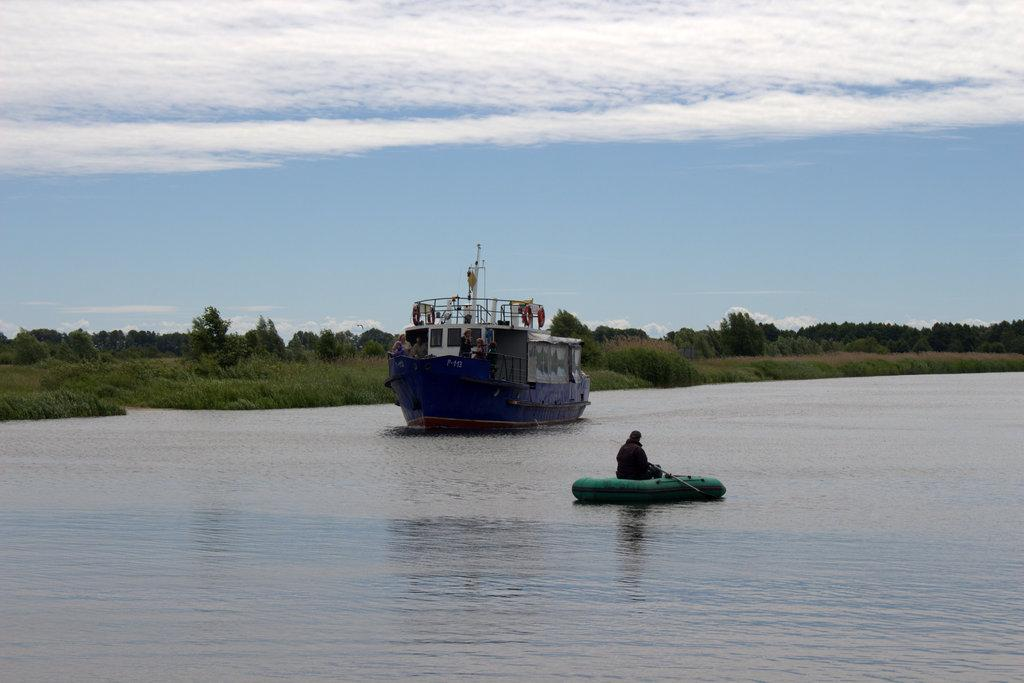What is floating on the water in the image? There are boats floating on the water in the image. What else can be seen in the middle of the image besides the boats? There are plants in the middle of the image. What is visible at the top of the image? The sky is visible at the top of the image. Can you see any cherries growing on the plants in the image? There is no mention of cherries or any specific type of plant in the image, so it cannot be determined if cherries are present. 